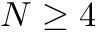Convert formula to latex. <formula><loc_0><loc_0><loc_500><loc_500>N \geq 4</formula> 